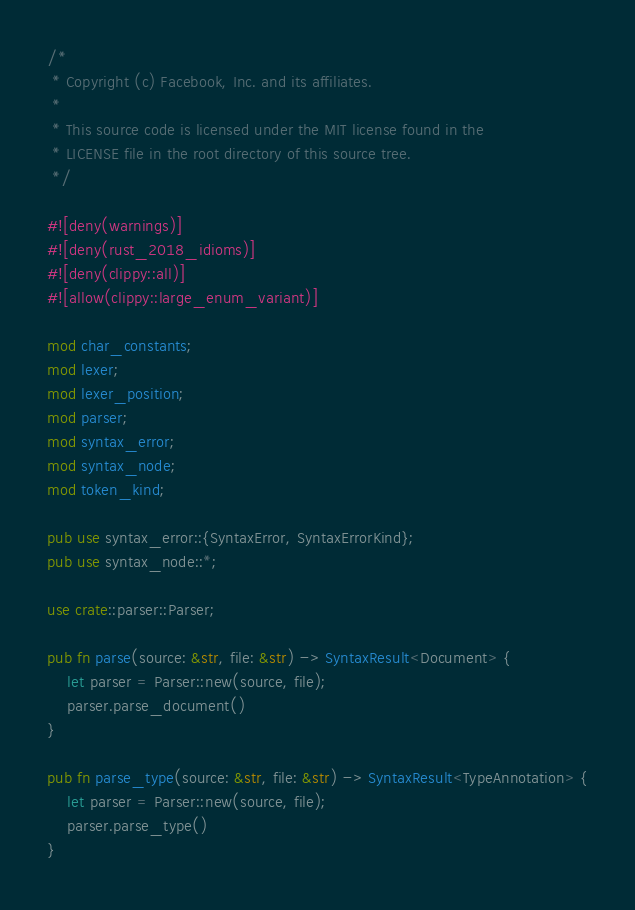Convert code to text. <code><loc_0><loc_0><loc_500><loc_500><_Rust_>/*
 * Copyright (c) Facebook, Inc. and its affiliates.
 *
 * This source code is licensed under the MIT license found in the
 * LICENSE file in the root directory of this source tree.
 */

#![deny(warnings)]
#![deny(rust_2018_idioms)]
#![deny(clippy::all)]
#![allow(clippy::large_enum_variant)]

mod char_constants;
mod lexer;
mod lexer_position;
mod parser;
mod syntax_error;
mod syntax_node;
mod token_kind;

pub use syntax_error::{SyntaxError, SyntaxErrorKind};
pub use syntax_node::*;

use crate::parser::Parser;

pub fn parse(source: &str, file: &str) -> SyntaxResult<Document> {
    let parser = Parser::new(source, file);
    parser.parse_document()
}

pub fn parse_type(source: &str, file: &str) -> SyntaxResult<TypeAnnotation> {
    let parser = Parser::new(source, file);
    parser.parse_type()
}
</code> 